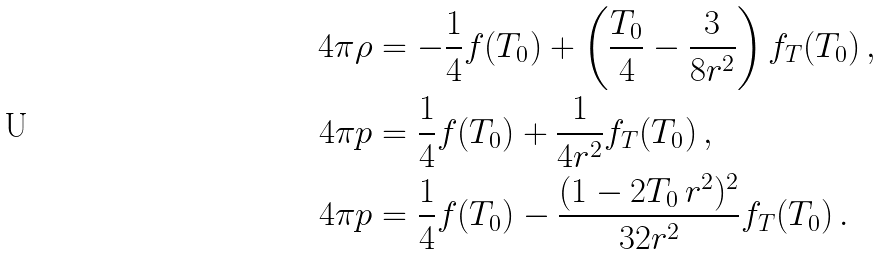Convert formula to latex. <formula><loc_0><loc_0><loc_500><loc_500>4 \pi \rho & = - \frac { 1 } { 4 } f ( T _ { 0 } ) + \left ( \frac { T _ { 0 } } { 4 } - \frac { 3 } { 8 r ^ { 2 } } \right ) f _ { T } ( T _ { 0 } ) \, , \\ 4 \pi p & = \frac { 1 } { 4 } f ( T _ { 0 } ) + \frac { 1 } { 4 r ^ { 2 } } f _ { T } ( T _ { 0 } ) \, , \\ 4 \pi p & = \frac { 1 } { 4 } f ( T _ { 0 } ) - \frac { ( 1 - 2 T _ { 0 } \, r ^ { 2 } ) ^ { 2 } } { 3 2 r ^ { 2 } } f _ { T } ( T _ { 0 } ) \, .</formula> 